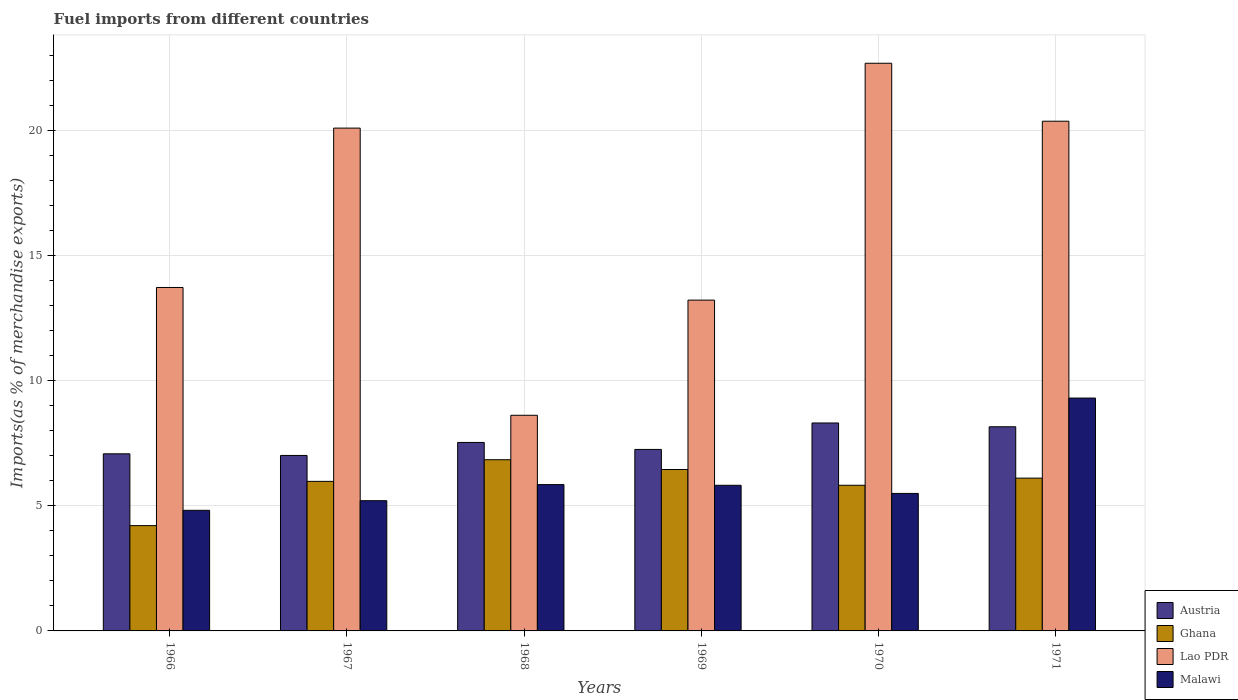How many different coloured bars are there?
Ensure brevity in your answer.  4. How many groups of bars are there?
Ensure brevity in your answer.  6. Are the number of bars per tick equal to the number of legend labels?
Give a very brief answer. Yes. Are the number of bars on each tick of the X-axis equal?
Make the answer very short. Yes. How many bars are there on the 2nd tick from the right?
Make the answer very short. 4. What is the label of the 6th group of bars from the left?
Give a very brief answer. 1971. In how many cases, is the number of bars for a given year not equal to the number of legend labels?
Your answer should be compact. 0. What is the percentage of imports to different countries in Austria in 1971?
Provide a short and direct response. 8.16. Across all years, what is the maximum percentage of imports to different countries in Austria?
Make the answer very short. 8.31. Across all years, what is the minimum percentage of imports to different countries in Ghana?
Your response must be concise. 4.21. In which year was the percentage of imports to different countries in Ghana maximum?
Keep it short and to the point. 1968. In which year was the percentage of imports to different countries in Ghana minimum?
Offer a very short reply. 1966. What is the total percentage of imports to different countries in Lao PDR in the graph?
Your answer should be compact. 98.76. What is the difference between the percentage of imports to different countries in Lao PDR in 1969 and that in 1971?
Keep it short and to the point. -7.15. What is the difference between the percentage of imports to different countries in Lao PDR in 1969 and the percentage of imports to different countries in Malawi in 1970?
Your answer should be very brief. 7.73. What is the average percentage of imports to different countries in Lao PDR per year?
Make the answer very short. 16.46. In the year 1966, what is the difference between the percentage of imports to different countries in Malawi and percentage of imports to different countries in Ghana?
Your answer should be very brief. 0.61. What is the ratio of the percentage of imports to different countries in Malawi in 1966 to that in 1969?
Ensure brevity in your answer.  0.83. Is the percentage of imports to different countries in Ghana in 1966 less than that in 1970?
Your answer should be compact. Yes. Is the difference between the percentage of imports to different countries in Malawi in 1968 and 1971 greater than the difference between the percentage of imports to different countries in Ghana in 1968 and 1971?
Keep it short and to the point. No. What is the difference between the highest and the second highest percentage of imports to different countries in Ghana?
Your response must be concise. 0.39. What is the difference between the highest and the lowest percentage of imports to different countries in Lao PDR?
Your answer should be compact. 14.07. Is it the case that in every year, the sum of the percentage of imports to different countries in Lao PDR and percentage of imports to different countries in Ghana is greater than the sum of percentage of imports to different countries in Malawi and percentage of imports to different countries in Austria?
Keep it short and to the point. Yes. What does the 4th bar from the left in 1967 represents?
Give a very brief answer. Malawi. What does the 2nd bar from the right in 1968 represents?
Your answer should be very brief. Lao PDR. Is it the case that in every year, the sum of the percentage of imports to different countries in Lao PDR and percentage of imports to different countries in Malawi is greater than the percentage of imports to different countries in Ghana?
Provide a short and direct response. Yes. How many bars are there?
Ensure brevity in your answer.  24. Are all the bars in the graph horizontal?
Your answer should be very brief. No. How many years are there in the graph?
Offer a terse response. 6. Does the graph contain any zero values?
Offer a very short reply. No. Does the graph contain grids?
Provide a succinct answer. Yes. What is the title of the graph?
Provide a short and direct response. Fuel imports from different countries. Does "Chile" appear as one of the legend labels in the graph?
Ensure brevity in your answer.  No. What is the label or title of the X-axis?
Your answer should be very brief. Years. What is the label or title of the Y-axis?
Offer a very short reply. Imports(as % of merchandise exports). What is the Imports(as % of merchandise exports) in Austria in 1966?
Your response must be concise. 7.08. What is the Imports(as % of merchandise exports) in Ghana in 1966?
Your answer should be very brief. 4.21. What is the Imports(as % of merchandise exports) in Lao PDR in 1966?
Provide a succinct answer. 13.73. What is the Imports(as % of merchandise exports) of Malawi in 1966?
Offer a terse response. 4.82. What is the Imports(as % of merchandise exports) in Austria in 1967?
Keep it short and to the point. 7.02. What is the Imports(as % of merchandise exports) of Ghana in 1967?
Give a very brief answer. 5.98. What is the Imports(as % of merchandise exports) in Lao PDR in 1967?
Your response must be concise. 20.1. What is the Imports(as % of merchandise exports) in Malawi in 1967?
Your answer should be very brief. 5.21. What is the Imports(as % of merchandise exports) of Austria in 1968?
Make the answer very short. 7.54. What is the Imports(as % of merchandise exports) of Ghana in 1968?
Make the answer very short. 6.84. What is the Imports(as % of merchandise exports) in Lao PDR in 1968?
Offer a terse response. 8.62. What is the Imports(as % of merchandise exports) in Malawi in 1968?
Offer a very short reply. 5.85. What is the Imports(as % of merchandise exports) of Austria in 1969?
Keep it short and to the point. 7.26. What is the Imports(as % of merchandise exports) of Ghana in 1969?
Offer a terse response. 6.45. What is the Imports(as % of merchandise exports) in Lao PDR in 1969?
Give a very brief answer. 13.23. What is the Imports(as % of merchandise exports) of Malawi in 1969?
Offer a terse response. 5.82. What is the Imports(as % of merchandise exports) in Austria in 1970?
Your response must be concise. 8.31. What is the Imports(as % of merchandise exports) in Ghana in 1970?
Offer a terse response. 5.82. What is the Imports(as % of merchandise exports) of Lao PDR in 1970?
Give a very brief answer. 22.7. What is the Imports(as % of merchandise exports) of Malawi in 1970?
Keep it short and to the point. 5.5. What is the Imports(as % of merchandise exports) in Austria in 1971?
Make the answer very short. 8.16. What is the Imports(as % of merchandise exports) in Ghana in 1971?
Keep it short and to the point. 6.11. What is the Imports(as % of merchandise exports) in Lao PDR in 1971?
Provide a succinct answer. 20.38. What is the Imports(as % of merchandise exports) in Malawi in 1971?
Your response must be concise. 9.31. Across all years, what is the maximum Imports(as % of merchandise exports) of Austria?
Your response must be concise. 8.31. Across all years, what is the maximum Imports(as % of merchandise exports) of Ghana?
Your answer should be very brief. 6.84. Across all years, what is the maximum Imports(as % of merchandise exports) in Lao PDR?
Keep it short and to the point. 22.7. Across all years, what is the maximum Imports(as % of merchandise exports) of Malawi?
Offer a very short reply. 9.31. Across all years, what is the minimum Imports(as % of merchandise exports) in Austria?
Your response must be concise. 7.02. Across all years, what is the minimum Imports(as % of merchandise exports) of Ghana?
Keep it short and to the point. 4.21. Across all years, what is the minimum Imports(as % of merchandise exports) of Lao PDR?
Offer a very short reply. 8.62. Across all years, what is the minimum Imports(as % of merchandise exports) of Malawi?
Keep it short and to the point. 4.82. What is the total Imports(as % of merchandise exports) in Austria in the graph?
Your response must be concise. 45.37. What is the total Imports(as % of merchandise exports) in Ghana in the graph?
Your answer should be compact. 35.42. What is the total Imports(as % of merchandise exports) of Lao PDR in the graph?
Provide a succinct answer. 98.76. What is the total Imports(as % of merchandise exports) in Malawi in the graph?
Your answer should be compact. 36.51. What is the difference between the Imports(as % of merchandise exports) in Austria in 1966 and that in 1967?
Your answer should be compact. 0.07. What is the difference between the Imports(as % of merchandise exports) in Ghana in 1966 and that in 1967?
Make the answer very short. -1.77. What is the difference between the Imports(as % of merchandise exports) in Lao PDR in 1966 and that in 1967?
Offer a terse response. -6.37. What is the difference between the Imports(as % of merchandise exports) in Malawi in 1966 and that in 1967?
Your answer should be compact. -0.39. What is the difference between the Imports(as % of merchandise exports) of Austria in 1966 and that in 1968?
Ensure brevity in your answer.  -0.45. What is the difference between the Imports(as % of merchandise exports) in Ghana in 1966 and that in 1968?
Keep it short and to the point. -2.63. What is the difference between the Imports(as % of merchandise exports) of Lao PDR in 1966 and that in 1968?
Your answer should be very brief. 5.11. What is the difference between the Imports(as % of merchandise exports) in Malawi in 1966 and that in 1968?
Provide a short and direct response. -1.03. What is the difference between the Imports(as % of merchandise exports) of Austria in 1966 and that in 1969?
Offer a very short reply. -0.18. What is the difference between the Imports(as % of merchandise exports) of Ghana in 1966 and that in 1969?
Your answer should be very brief. -2.24. What is the difference between the Imports(as % of merchandise exports) of Lao PDR in 1966 and that in 1969?
Your answer should be compact. 0.51. What is the difference between the Imports(as % of merchandise exports) in Malawi in 1966 and that in 1969?
Make the answer very short. -1. What is the difference between the Imports(as % of merchandise exports) in Austria in 1966 and that in 1970?
Offer a terse response. -1.23. What is the difference between the Imports(as % of merchandise exports) in Ghana in 1966 and that in 1970?
Offer a terse response. -1.61. What is the difference between the Imports(as % of merchandise exports) of Lao PDR in 1966 and that in 1970?
Keep it short and to the point. -8.96. What is the difference between the Imports(as % of merchandise exports) of Malawi in 1966 and that in 1970?
Provide a succinct answer. -0.68. What is the difference between the Imports(as % of merchandise exports) of Austria in 1966 and that in 1971?
Your answer should be very brief. -1.08. What is the difference between the Imports(as % of merchandise exports) of Ghana in 1966 and that in 1971?
Your answer should be compact. -1.9. What is the difference between the Imports(as % of merchandise exports) of Lao PDR in 1966 and that in 1971?
Provide a short and direct response. -6.65. What is the difference between the Imports(as % of merchandise exports) of Malawi in 1966 and that in 1971?
Give a very brief answer. -4.49. What is the difference between the Imports(as % of merchandise exports) of Austria in 1967 and that in 1968?
Your answer should be very brief. -0.52. What is the difference between the Imports(as % of merchandise exports) in Ghana in 1967 and that in 1968?
Give a very brief answer. -0.87. What is the difference between the Imports(as % of merchandise exports) of Lao PDR in 1967 and that in 1968?
Provide a short and direct response. 11.48. What is the difference between the Imports(as % of merchandise exports) of Malawi in 1967 and that in 1968?
Provide a short and direct response. -0.64. What is the difference between the Imports(as % of merchandise exports) of Austria in 1967 and that in 1969?
Make the answer very short. -0.24. What is the difference between the Imports(as % of merchandise exports) of Ghana in 1967 and that in 1969?
Your answer should be compact. -0.47. What is the difference between the Imports(as % of merchandise exports) in Lao PDR in 1967 and that in 1969?
Provide a short and direct response. 6.88. What is the difference between the Imports(as % of merchandise exports) of Malawi in 1967 and that in 1969?
Your answer should be compact. -0.62. What is the difference between the Imports(as % of merchandise exports) of Austria in 1967 and that in 1970?
Give a very brief answer. -1.3. What is the difference between the Imports(as % of merchandise exports) in Ghana in 1967 and that in 1970?
Provide a short and direct response. 0.16. What is the difference between the Imports(as % of merchandise exports) in Lao PDR in 1967 and that in 1970?
Provide a succinct answer. -2.59. What is the difference between the Imports(as % of merchandise exports) of Malawi in 1967 and that in 1970?
Your answer should be very brief. -0.29. What is the difference between the Imports(as % of merchandise exports) in Austria in 1967 and that in 1971?
Make the answer very short. -1.15. What is the difference between the Imports(as % of merchandise exports) of Ghana in 1967 and that in 1971?
Provide a short and direct response. -0.13. What is the difference between the Imports(as % of merchandise exports) of Lao PDR in 1967 and that in 1971?
Keep it short and to the point. -0.28. What is the difference between the Imports(as % of merchandise exports) of Malawi in 1967 and that in 1971?
Make the answer very short. -4.1. What is the difference between the Imports(as % of merchandise exports) of Austria in 1968 and that in 1969?
Provide a succinct answer. 0.28. What is the difference between the Imports(as % of merchandise exports) of Ghana in 1968 and that in 1969?
Keep it short and to the point. 0.39. What is the difference between the Imports(as % of merchandise exports) in Lao PDR in 1968 and that in 1969?
Provide a short and direct response. -4.6. What is the difference between the Imports(as % of merchandise exports) of Malawi in 1968 and that in 1969?
Ensure brevity in your answer.  0.03. What is the difference between the Imports(as % of merchandise exports) of Austria in 1968 and that in 1970?
Provide a short and direct response. -0.78. What is the difference between the Imports(as % of merchandise exports) in Ghana in 1968 and that in 1970?
Your response must be concise. 1.02. What is the difference between the Imports(as % of merchandise exports) of Lao PDR in 1968 and that in 1970?
Keep it short and to the point. -14.07. What is the difference between the Imports(as % of merchandise exports) of Malawi in 1968 and that in 1970?
Give a very brief answer. 0.35. What is the difference between the Imports(as % of merchandise exports) in Austria in 1968 and that in 1971?
Provide a short and direct response. -0.63. What is the difference between the Imports(as % of merchandise exports) in Ghana in 1968 and that in 1971?
Your answer should be compact. 0.74. What is the difference between the Imports(as % of merchandise exports) in Lao PDR in 1968 and that in 1971?
Your answer should be very brief. -11.76. What is the difference between the Imports(as % of merchandise exports) of Malawi in 1968 and that in 1971?
Give a very brief answer. -3.46. What is the difference between the Imports(as % of merchandise exports) in Austria in 1969 and that in 1970?
Your answer should be compact. -1.06. What is the difference between the Imports(as % of merchandise exports) of Ghana in 1969 and that in 1970?
Your answer should be very brief. 0.63. What is the difference between the Imports(as % of merchandise exports) in Lao PDR in 1969 and that in 1970?
Offer a very short reply. -9.47. What is the difference between the Imports(as % of merchandise exports) in Malawi in 1969 and that in 1970?
Give a very brief answer. 0.33. What is the difference between the Imports(as % of merchandise exports) in Austria in 1969 and that in 1971?
Keep it short and to the point. -0.91. What is the difference between the Imports(as % of merchandise exports) of Ghana in 1969 and that in 1971?
Give a very brief answer. 0.34. What is the difference between the Imports(as % of merchandise exports) in Lao PDR in 1969 and that in 1971?
Offer a terse response. -7.15. What is the difference between the Imports(as % of merchandise exports) of Malawi in 1969 and that in 1971?
Provide a succinct answer. -3.49. What is the difference between the Imports(as % of merchandise exports) of Austria in 1970 and that in 1971?
Offer a very short reply. 0.15. What is the difference between the Imports(as % of merchandise exports) of Ghana in 1970 and that in 1971?
Your response must be concise. -0.29. What is the difference between the Imports(as % of merchandise exports) in Lao PDR in 1970 and that in 1971?
Keep it short and to the point. 2.32. What is the difference between the Imports(as % of merchandise exports) in Malawi in 1970 and that in 1971?
Provide a succinct answer. -3.81. What is the difference between the Imports(as % of merchandise exports) in Austria in 1966 and the Imports(as % of merchandise exports) in Ghana in 1967?
Provide a short and direct response. 1.1. What is the difference between the Imports(as % of merchandise exports) of Austria in 1966 and the Imports(as % of merchandise exports) of Lao PDR in 1967?
Provide a succinct answer. -13.02. What is the difference between the Imports(as % of merchandise exports) in Austria in 1966 and the Imports(as % of merchandise exports) in Malawi in 1967?
Make the answer very short. 1.87. What is the difference between the Imports(as % of merchandise exports) of Ghana in 1966 and the Imports(as % of merchandise exports) of Lao PDR in 1967?
Your answer should be compact. -15.89. What is the difference between the Imports(as % of merchandise exports) of Ghana in 1966 and the Imports(as % of merchandise exports) of Malawi in 1967?
Make the answer very short. -1. What is the difference between the Imports(as % of merchandise exports) in Lao PDR in 1966 and the Imports(as % of merchandise exports) in Malawi in 1967?
Give a very brief answer. 8.52. What is the difference between the Imports(as % of merchandise exports) in Austria in 1966 and the Imports(as % of merchandise exports) in Ghana in 1968?
Your answer should be very brief. 0.24. What is the difference between the Imports(as % of merchandise exports) of Austria in 1966 and the Imports(as % of merchandise exports) of Lao PDR in 1968?
Keep it short and to the point. -1.54. What is the difference between the Imports(as % of merchandise exports) in Austria in 1966 and the Imports(as % of merchandise exports) in Malawi in 1968?
Your response must be concise. 1.23. What is the difference between the Imports(as % of merchandise exports) in Ghana in 1966 and the Imports(as % of merchandise exports) in Lao PDR in 1968?
Offer a very short reply. -4.41. What is the difference between the Imports(as % of merchandise exports) in Ghana in 1966 and the Imports(as % of merchandise exports) in Malawi in 1968?
Provide a succinct answer. -1.64. What is the difference between the Imports(as % of merchandise exports) of Lao PDR in 1966 and the Imports(as % of merchandise exports) of Malawi in 1968?
Your answer should be compact. 7.88. What is the difference between the Imports(as % of merchandise exports) in Austria in 1966 and the Imports(as % of merchandise exports) in Ghana in 1969?
Your answer should be compact. 0.63. What is the difference between the Imports(as % of merchandise exports) of Austria in 1966 and the Imports(as % of merchandise exports) of Lao PDR in 1969?
Keep it short and to the point. -6.15. What is the difference between the Imports(as % of merchandise exports) in Austria in 1966 and the Imports(as % of merchandise exports) in Malawi in 1969?
Offer a terse response. 1.26. What is the difference between the Imports(as % of merchandise exports) in Ghana in 1966 and the Imports(as % of merchandise exports) in Lao PDR in 1969?
Provide a succinct answer. -9.02. What is the difference between the Imports(as % of merchandise exports) of Ghana in 1966 and the Imports(as % of merchandise exports) of Malawi in 1969?
Your answer should be very brief. -1.61. What is the difference between the Imports(as % of merchandise exports) in Lao PDR in 1966 and the Imports(as % of merchandise exports) in Malawi in 1969?
Ensure brevity in your answer.  7.91. What is the difference between the Imports(as % of merchandise exports) of Austria in 1966 and the Imports(as % of merchandise exports) of Ghana in 1970?
Make the answer very short. 1.26. What is the difference between the Imports(as % of merchandise exports) in Austria in 1966 and the Imports(as % of merchandise exports) in Lao PDR in 1970?
Offer a very short reply. -15.62. What is the difference between the Imports(as % of merchandise exports) of Austria in 1966 and the Imports(as % of merchandise exports) of Malawi in 1970?
Your answer should be very brief. 1.58. What is the difference between the Imports(as % of merchandise exports) of Ghana in 1966 and the Imports(as % of merchandise exports) of Lao PDR in 1970?
Offer a very short reply. -18.49. What is the difference between the Imports(as % of merchandise exports) of Ghana in 1966 and the Imports(as % of merchandise exports) of Malawi in 1970?
Your answer should be very brief. -1.29. What is the difference between the Imports(as % of merchandise exports) in Lao PDR in 1966 and the Imports(as % of merchandise exports) in Malawi in 1970?
Offer a very short reply. 8.23. What is the difference between the Imports(as % of merchandise exports) of Austria in 1966 and the Imports(as % of merchandise exports) of Ghana in 1971?
Offer a terse response. 0.97. What is the difference between the Imports(as % of merchandise exports) in Austria in 1966 and the Imports(as % of merchandise exports) in Lao PDR in 1971?
Offer a very short reply. -13.3. What is the difference between the Imports(as % of merchandise exports) in Austria in 1966 and the Imports(as % of merchandise exports) in Malawi in 1971?
Provide a short and direct response. -2.23. What is the difference between the Imports(as % of merchandise exports) of Ghana in 1966 and the Imports(as % of merchandise exports) of Lao PDR in 1971?
Provide a succinct answer. -16.17. What is the difference between the Imports(as % of merchandise exports) in Ghana in 1966 and the Imports(as % of merchandise exports) in Malawi in 1971?
Your response must be concise. -5.1. What is the difference between the Imports(as % of merchandise exports) of Lao PDR in 1966 and the Imports(as % of merchandise exports) of Malawi in 1971?
Offer a very short reply. 4.42. What is the difference between the Imports(as % of merchandise exports) of Austria in 1967 and the Imports(as % of merchandise exports) of Ghana in 1968?
Make the answer very short. 0.17. What is the difference between the Imports(as % of merchandise exports) in Austria in 1967 and the Imports(as % of merchandise exports) in Lao PDR in 1968?
Offer a terse response. -1.61. What is the difference between the Imports(as % of merchandise exports) in Austria in 1967 and the Imports(as % of merchandise exports) in Malawi in 1968?
Make the answer very short. 1.17. What is the difference between the Imports(as % of merchandise exports) in Ghana in 1967 and the Imports(as % of merchandise exports) in Lao PDR in 1968?
Your response must be concise. -2.64. What is the difference between the Imports(as % of merchandise exports) in Ghana in 1967 and the Imports(as % of merchandise exports) in Malawi in 1968?
Provide a succinct answer. 0.13. What is the difference between the Imports(as % of merchandise exports) of Lao PDR in 1967 and the Imports(as % of merchandise exports) of Malawi in 1968?
Provide a short and direct response. 14.25. What is the difference between the Imports(as % of merchandise exports) in Austria in 1967 and the Imports(as % of merchandise exports) in Ghana in 1969?
Your answer should be compact. 0.56. What is the difference between the Imports(as % of merchandise exports) of Austria in 1967 and the Imports(as % of merchandise exports) of Lao PDR in 1969?
Your response must be concise. -6.21. What is the difference between the Imports(as % of merchandise exports) of Austria in 1967 and the Imports(as % of merchandise exports) of Malawi in 1969?
Give a very brief answer. 1.19. What is the difference between the Imports(as % of merchandise exports) of Ghana in 1967 and the Imports(as % of merchandise exports) of Lao PDR in 1969?
Ensure brevity in your answer.  -7.25. What is the difference between the Imports(as % of merchandise exports) in Ghana in 1967 and the Imports(as % of merchandise exports) in Malawi in 1969?
Give a very brief answer. 0.16. What is the difference between the Imports(as % of merchandise exports) of Lao PDR in 1967 and the Imports(as % of merchandise exports) of Malawi in 1969?
Offer a very short reply. 14.28. What is the difference between the Imports(as % of merchandise exports) in Austria in 1967 and the Imports(as % of merchandise exports) in Ghana in 1970?
Provide a succinct answer. 1.19. What is the difference between the Imports(as % of merchandise exports) of Austria in 1967 and the Imports(as % of merchandise exports) of Lao PDR in 1970?
Your response must be concise. -15.68. What is the difference between the Imports(as % of merchandise exports) of Austria in 1967 and the Imports(as % of merchandise exports) of Malawi in 1970?
Offer a terse response. 1.52. What is the difference between the Imports(as % of merchandise exports) in Ghana in 1967 and the Imports(as % of merchandise exports) in Lao PDR in 1970?
Offer a terse response. -16.72. What is the difference between the Imports(as % of merchandise exports) of Ghana in 1967 and the Imports(as % of merchandise exports) of Malawi in 1970?
Provide a succinct answer. 0.48. What is the difference between the Imports(as % of merchandise exports) of Lao PDR in 1967 and the Imports(as % of merchandise exports) of Malawi in 1970?
Make the answer very short. 14.61. What is the difference between the Imports(as % of merchandise exports) of Austria in 1967 and the Imports(as % of merchandise exports) of Ghana in 1971?
Make the answer very short. 0.91. What is the difference between the Imports(as % of merchandise exports) in Austria in 1967 and the Imports(as % of merchandise exports) in Lao PDR in 1971?
Provide a short and direct response. -13.36. What is the difference between the Imports(as % of merchandise exports) of Austria in 1967 and the Imports(as % of merchandise exports) of Malawi in 1971?
Your response must be concise. -2.29. What is the difference between the Imports(as % of merchandise exports) of Ghana in 1967 and the Imports(as % of merchandise exports) of Lao PDR in 1971?
Your response must be concise. -14.4. What is the difference between the Imports(as % of merchandise exports) of Ghana in 1967 and the Imports(as % of merchandise exports) of Malawi in 1971?
Make the answer very short. -3.33. What is the difference between the Imports(as % of merchandise exports) in Lao PDR in 1967 and the Imports(as % of merchandise exports) in Malawi in 1971?
Your answer should be compact. 10.79. What is the difference between the Imports(as % of merchandise exports) of Austria in 1968 and the Imports(as % of merchandise exports) of Ghana in 1969?
Your response must be concise. 1.08. What is the difference between the Imports(as % of merchandise exports) of Austria in 1968 and the Imports(as % of merchandise exports) of Lao PDR in 1969?
Your answer should be very brief. -5.69. What is the difference between the Imports(as % of merchandise exports) of Austria in 1968 and the Imports(as % of merchandise exports) of Malawi in 1969?
Your answer should be very brief. 1.71. What is the difference between the Imports(as % of merchandise exports) in Ghana in 1968 and the Imports(as % of merchandise exports) in Lao PDR in 1969?
Offer a very short reply. -6.38. What is the difference between the Imports(as % of merchandise exports) in Ghana in 1968 and the Imports(as % of merchandise exports) in Malawi in 1969?
Ensure brevity in your answer.  1.02. What is the difference between the Imports(as % of merchandise exports) of Lao PDR in 1968 and the Imports(as % of merchandise exports) of Malawi in 1969?
Make the answer very short. 2.8. What is the difference between the Imports(as % of merchandise exports) of Austria in 1968 and the Imports(as % of merchandise exports) of Ghana in 1970?
Provide a short and direct response. 1.71. What is the difference between the Imports(as % of merchandise exports) in Austria in 1968 and the Imports(as % of merchandise exports) in Lao PDR in 1970?
Ensure brevity in your answer.  -15.16. What is the difference between the Imports(as % of merchandise exports) in Austria in 1968 and the Imports(as % of merchandise exports) in Malawi in 1970?
Offer a terse response. 2.04. What is the difference between the Imports(as % of merchandise exports) in Ghana in 1968 and the Imports(as % of merchandise exports) in Lao PDR in 1970?
Offer a terse response. -15.85. What is the difference between the Imports(as % of merchandise exports) in Ghana in 1968 and the Imports(as % of merchandise exports) in Malawi in 1970?
Your answer should be very brief. 1.35. What is the difference between the Imports(as % of merchandise exports) of Lao PDR in 1968 and the Imports(as % of merchandise exports) of Malawi in 1970?
Keep it short and to the point. 3.13. What is the difference between the Imports(as % of merchandise exports) in Austria in 1968 and the Imports(as % of merchandise exports) in Ghana in 1971?
Make the answer very short. 1.43. What is the difference between the Imports(as % of merchandise exports) in Austria in 1968 and the Imports(as % of merchandise exports) in Lao PDR in 1971?
Your response must be concise. -12.84. What is the difference between the Imports(as % of merchandise exports) in Austria in 1968 and the Imports(as % of merchandise exports) in Malawi in 1971?
Give a very brief answer. -1.77. What is the difference between the Imports(as % of merchandise exports) of Ghana in 1968 and the Imports(as % of merchandise exports) of Lao PDR in 1971?
Keep it short and to the point. -13.53. What is the difference between the Imports(as % of merchandise exports) in Ghana in 1968 and the Imports(as % of merchandise exports) in Malawi in 1971?
Your response must be concise. -2.47. What is the difference between the Imports(as % of merchandise exports) of Lao PDR in 1968 and the Imports(as % of merchandise exports) of Malawi in 1971?
Make the answer very short. -0.69. What is the difference between the Imports(as % of merchandise exports) in Austria in 1969 and the Imports(as % of merchandise exports) in Ghana in 1970?
Offer a very short reply. 1.43. What is the difference between the Imports(as % of merchandise exports) in Austria in 1969 and the Imports(as % of merchandise exports) in Lao PDR in 1970?
Provide a short and direct response. -15.44. What is the difference between the Imports(as % of merchandise exports) in Austria in 1969 and the Imports(as % of merchandise exports) in Malawi in 1970?
Ensure brevity in your answer.  1.76. What is the difference between the Imports(as % of merchandise exports) of Ghana in 1969 and the Imports(as % of merchandise exports) of Lao PDR in 1970?
Provide a succinct answer. -16.24. What is the difference between the Imports(as % of merchandise exports) of Ghana in 1969 and the Imports(as % of merchandise exports) of Malawi in 1970?
Offer a very short reply. 0.96. What is the difference between the Imports(as % of merchandise exports) in Lao PDR in 1969 and the Imports(as % of merchandise exports) in Malawi in 1970?
Offer a very short reply. 7.73. What is the difference between the Imports(as % of merchandise exports) of Austria in 1969 and the Imports(as % of merchandise exports) of Ghana in 1971?
Offer a terse response. 1.15. What is the difference between the Imports(as % of merchandise exports) in Austria in 1969 and the Imports(as % of merchandise exports) in Lao PDR in 1971?
Provide a short and direct response. -13.12. What is the difference between the Imports(as % of merchandise exports) in Austria in 1969 and the Imports(as % of merchandise exports) in Malawi in 1971?
Offer a terse response. -2.05. What is the difference between the Imports(as % of merchandise exports) in Ghana in 1969 and the Imports(as % of merchandise exports) in Lao PDR in 1971?
Your answer should be compact. -13.93. What is the difference between the Imports(as % of merchandise exports) of Ghana in 1969 and the Imports(as % of merchandise exports) of Malawi in 1971?
Your answer should be very brief. -2.86. What is the difference between the Imports(as % of merchandise exports) in Lao PDR in 1969 and the Imports(as % of merchandise exports) in Malawi in 1971?
Your answer should be compact. 3.92. What is the difference between the Imports(as % of merchandise exports) in Austria in 1970 and the Imports(as % of merchandise exports) in Ghana in 1971?
Offer a terse response. 2.21. What is the difference between the Imports(as % of merchandise exports) of Austria in 1970 and the Imports(as % of merchandise exports) of Lao PDR in 1971?
Your response must be concise. -12.07. What is the difference between the Imports(as % of merchandise exports) in Austria in 1970 and the Imports(as % of merchandise exports) in Malawi in 1971?
Make the answer very short. -1. What is the difference between the Imports(as % of merchandise exports) of Ghana in 1970 and the Imports(as % of merchandise exports) of Lao PDR in 1971?
Provide a succinct answer. -14.56. What is the difference between the Imports(as % of merchandise exports) of Ghana in 1970 and the Imports(as % of merchandise exports) of Malawi in 1971?
Keep it short and to the point. -3.49. What is the difference between the Imports(as % of merchandise exports) in Lao PDR in 1970 and the Imports(as % of merchandise exports) in Malawi in 1971?
Offer a very short reply. 13.39. What is the average Imports(as % of merchandise exports) of Austria per year?
Offer a terse response. 7.56. What is the average Imports(as % of merchandise exports) in Ghana per year?
Give a very brief answer. 5.9. What is the average Imports(as % of merchandise exports) of Lao PDR per year?
Make the answer very short. 16.46. What is the average Imports(as % of merchandise exports) of Malawi per year?
Make the answer very short. 6.08. In the year 1966, what is the difference between the Imports(as % of merchandise exports) in Austria and Imports(as % of merchandise exports) in Ghana?
Provide a short and direct response. 2.87. In the year 1966, what is the difference between the Imports(as % of merchandise exports) in Austria and Imports(as % of merchandise exports) in Lao PDR?
Make the answer very short. -6.65. In the year 1966, what is the difference between the Imports(as % of merchandise exports) in Austria and Imports(as % of merchandise exports) in Malawi?
Provide a short and direct response. 2.26. In the year 1966, what is the difference between the Imports(as % of merchandise exports) of Ghana and Imports(as % of merchandise exports) of Lao PDR?
Your answer should be compact. -9.52. In the year 1966, what is the difference between the Imports(as % of merchandise exports) of Ghana and Imports(as % of merchandise exports) of Malawi?
Your answer should be compact. -0.61. In the year 1966, what is the difference between the Imports(as % of merchandise exports) of Lao PDR and Imports(as % of merchandise exports) of Malawi?
Provide a short and direct response. 8.91. In the year 1967, what is the difference between the Imports(as % of merchandise exports) in Austria and Imports(as % of merchandise exports) in Ghana?
Provide a succinct answer. 1.04. In the year 1967, what is the difference between the Imports(as % of merchandise exports) of Austria and Imports(as % of merchandise exports) of Lao PDR?
Provide a short and direct response. -13.09. In the year 1967, what is the difference between the Imports(as % of merchandise exports) in Austria and Imports(as % of merchandise exports) in Malawi?
Your answer should be compact. 1.81. In the year 1967, what is the difference between the Imports(as % of merchandise exports) in Ghana and Imports(as % of merchandise exports) in Lao PDR?
Offer a very short reply. -14.12. In the year 1967, what is the difference between the Imports(as % of merchandise exports) in Ghana and Imports(as % of merchandise exports) in Malawi?
Your response must be concise. 0.77. In the year 1967, what is the difference between the Imports(as % of merchandise exports) in Lao PDR and Imports(as % of merchandise exports) in Malawi?
Make the answer very short. 14.9. In the year 1968, what is the difference between the Imports(as % of merchandise exports) of Austria and Imports(as % of merchandise exports) of Ghana?
Make the answer very short. 0.69. In the year 1968, what is the difference between the Imports(as % of merchandise exports) of Austria and Imports(as % of merchandise exports) of Lao PDR?
Make the answer very short. -1.09. In the year 1968, what is the difference between the Imports(as % of merchandise exports) of Austria and Imports(as % of merchandise exports) of Malawi?
Offer a terse response. 1.69. In the year 1968, what is the difference between the Imports(as % of merchandise exports) of Ghana and Imports(as % of merchandise exports) of Lao PDR?
Your response must be concise. -1.78. In the year 1968, what is the difference between the Imports(as % of merchandise exports) of Lao PDR and Imports(as % of merchandise exports) of Malawi?
Provide a succinct answer. 2.77. In the year 1969, what is the difference between the Imports(as % of merchandise exports) in Austria and Imports(as % of merchandise exports) in Ghana?
Ensure brevity in your answer.  0.8. In the year 1969, what is the difference between the Imports(as % of merchandise exports) in Austria and Imports(as % of merchandise exports) in Lao PDR?
Give a very brief answer. -5.97. In the year 1969, what is the difference between the Imports(as % of merchandise exports) of Austria and Imports(as % of merchandise exports) of Malawi?
Your answer should be compact. 1.43. In the year 1969, what is the difference between the Imports(as % of merchandise exports) of Ghana and Imports(as % of merchandise exports) of Lao PDR?
Your answer should be very brief. -6.77. In the year 1969, what is the difference between the Imports(as % of merchandise exports) in Ghana and Imports(as % of merchandise exports) in Malawi?
Ensure brevity in your answer.  0.63. In the year 1969, what is the difference between the Imports(as % of merchandise exports) in Lao PDR and Imports(as % of merchandise exports) in Malawi?
Your answer should be compact. 7.4. In the year 1970, what is the difference between the Imports(as % of merchandise exports) of Austria and Imports(as % of merchandise exports) of Ghana?
Offer a very short reply. 2.49. In the year 1970, what is the difference between the Imports(as % of merchandise exports) of Austria and Imports(as % of merchandise exports) of Lao PDR?
Provide a succinct answer. -14.38. In the year 1970, what is the difference between the Imports(as % of merchandise exports) of Austria and Imports(as % of merchandise exports) of Malawi?
Your answer should be compact. 2.82. In the year 1970, what is the difference between the Imports(as % of merchandise exports) of Ghana and Imports(as % of merchandise exports) of Lao PDR?
Your response must be concise. -16.87. In the year 1970, what is the difference between the Imports(as % of merchandise exports) in Ghana and Imports(as % of merchandise exports) in Malawi?
Provide a short and direct response. 0.33. In the year 1970, what is the difference between the Imports(as % of merchandise exports) in Lao PDR and Imports(as % of merchandise exports) in Malawi?
Your answer should be very brief. 17.2. In the year 1971, what is the difference between the Imports(as % of merchandise exports) in Austria and Imports(as % of merchandise exports) in Ghana?
Offer a terse response. 2.05. In the year 1971, what is the difference between the Imports(as % of merchandise exports) of Austria and Imports(as % of merchandise exports) of Lao PDR?
Provide a succinct answer. -12.22. In the year 1971, what is the difference between the Imports(as % of merchandise exports) of Austria and Imports(as % of merchandise exports) of Malawi?
Keep it short and to the point. -1.15. In the year 1971, what is the difference between the Imports(as % of merchandise exports) in Ghana and Imports(as % of merchandise exports) in Lao PDR?
Your answer should be very brief. -14.27. In the year 1971, what is the difference between the Imports(as % of merchandise exports) of Ghana and Imports(as % of merchandise exports) of Malawi?
Provide a short and direct response. -3.2. In the year 1971, what is the difference between the Imports(as % of merchandise exports) of Lao PDR and Imports(as % of merchandise exports) of Malawi?
Give a very brief answer. 11.07. What is the ratio of the Imports(as % of merchandise exports) in Austria in 1966 to that in 1967?
Your response must be concise. 1.01. What is the ratio of the Imports(as % of merchandise exports) in Ghana in 1966 to that in 1967?
Provide a succinct answer. 0.7. What is the ratio of the Imports(as % of merchandise exports) of Lao PDR in 1966 to that in 1967?
Your answer should be compact. 0.68. What is the ratio of the Imports(as % of merchandise exports) in Malawi in 1966 to that in 1967?
Your answer should be very brief. 0.93. What is the ratio of the Imports(as % of merchandise exports) in Austria in 1966 to that in 1968?
Your answer should be very brief. 0.94. What is the ratio of the Imports(as % of merchandise exports) of Ghana in 1966 to that in 1968?
Ensure brevity in your answer.  0.62. What is the ratio of the Imports(as % of merchandise exports) of Lao PDR in 1966 to that in 1968?
Your response must be concise. 1.59. What is the ratio of the Imports(as % of merchandise exports) of Malawi in 1966 to that in 1968?
Your response must be concise. 0.82. What is the ratio of the Imports(as % of merchandise exports) in Austria in 1966 to that in 1969?
Keep it short and to the point. 0.98. What is the ratio of the Imports(as % of merchandise exports) of Ghana in 1966 to that in 1969?
Keep it short and to the point. 0.65. What is the ratio of the Imports(as % of merchandise exports) in Lao PDR in 1966 to that in 1969?
Make the answer very short. 1.04. What is the ratio of the Imports(as % of merchandise exports) of Malawi in 1966 to that in 1969?
Offer a terse response. 0.83. What is the ratio of the Imports(as % of merchandise exports) in Austria in 1966 to that in 1970?
Your response must be concise. 0.85. What is the ratio of the Imports(as % of merchandise exports) of Ghana in 1966 to that in 1970?
Your answer should be compact. 0.72. What is the ratio of the Imports(as % of merchandise exports) of Lao PDR in 1966 to that in 1970?
Offer a very short reply. 0.6. What is the ratio of the Imports(as % of merchandise exports) in Malawi in 1966 to that in 1970?
Make the answer very short. 0.88. What is the ratio of the Imports(as % of merchandise exports) of Austria in 1966 to that in 1971?
Keep it short and to the point. 0.87. What is the ratio of the Imports(as % of merchandise exports) in Ghana in 1966 to that in 1971?
Ensure brevity in your answer.  0.69. What is the ratio of the Imports(as % of merchandise exports) of Lao PDR in 1966 to that in 1971?
Offer a very short reply. 0.67. What is the ratio of the Imports(as % of merchandise exports) of Malawi in 1966 to that in 1971?
Ensure brevity in your answer.  0.52. What is the ratio of the Imports(as % of merchandise exports) in Austria in 1967 to that in 1968?
Offer a very short reply. 0.93. What is the ratio of the Imports(as % of merchandise exports) in Ghana in 1967 to that in 1968?
Offer a terse response. 0.87. What is the ratio of the Imports(as % of merchandise exports) in Lao PDR in 1967 to that in 1968?
Ensure brevity in your answer.  2.33. What is the ratio of the Imports(as % of merchandise exports) of Malawi in 1967 to that in 1968?
Offer a very short reply. 0.89. What is the ratio of the Imports(as % of merchandise exports) in Austria in 1967 to that in 1969?
Provide a short and direct response. 0.97. What is the ratio of the Imports(as % of merchandise exports) in Ghana in 1967 to that in 1969?
Ensure brevity in your answer.  0.93. What is the ratio of the Imports(as % of merchandise exports) in Lao PDR in 1967 to that in 1969?
Your answer should be compact. 1.52. What is the ratio of the Imports(as % of merchandise exports) in Malawi in 1967 to that in 1969?
Keep it short and to the point. 0.89. What is the ratio of the Imports(as % of merchandise exports) in Austria in 1967 to that in 1970?
Keep it short and to the point. 0.84. What is the ratio of the Imports(as % of merchandise exports) in Ghana in 1967 to that in 1970?
Offer a terse response. 1.03. What is the ratio of the Imports(as % of merchandise exports) of Lao PDR in 1967 to that in 1970?
Your answer should be very brief. 0.89. What is the ratio of the Imports(as % of merchandise exports) in Malawi in 1967 to that in 1970?
Offer a terse response. 0.95. What is the ratio of the Imports(as % of merchandise exports) of Austria in 1967 to that in 1971?
Your answer should be compact. 0.86. What is the ratio of the Imports(as % of merchandise exports) in Ghana in 1967 to that in 1971?
Give a very brief answer. 0.98. What is the ratio of the Imports(as % of merchandise exports) of Lao PDR in 1967 to that in 1971?
Give a very brief answer. 0.99. What is the ratio of the Imports(as % of merchandise exports) in Malawi in 1967 to that in 1971?
Give a very brief answer. 0.56. What is the ratio of the Imports(as % of merchandise exports) in Austria in 1968 to that in 1969?
Provide a short and direct response. 1.04. What is the ratio of the Imports(as % of merchandise exports) of Ghana in 1968 to that in 1969?
Give a very brief answer. 1.06. What is the ratio of the Imports(as % of merchandise exports) in Lao PDR in 1968 to that in 1969?
Ensure brevity in your answer.  0.65. What is the ratio of the Imports(as % of merchandise exports) of Austria in 1968 to that in 1970?
Make the answer very short. 0.91. What is the ratio of the Imports(as % of merchandise exports) in Ghana in 1968 to that in 1970?
Keep it short and to the point. 1.18. What is the ratio of the Imports(as % of merchandise exports) of Lao PDR in 1968 to that in 1970?
Offer a terse response. 0.38. What is the ratio of the Imports(as % of merchandise exports) in Malawi in 1968 to that in 1970?
Your answer should be very brief. 1.06. What is the ratio of the Imports(as % of merchandise exports) in Austria in 1968 to that in 1971?
Ensure brevity in your answer.  0.92. What is the ratio of the Imports(as % of merchandise exports) of Ghana in 1968 to that in 1971?
Give a very brief answer. 1.12. What is the ratio of the Imports(as % of merchandise exports) of Lao PDR in 1968 to that in 1971?
Your response must be concise. 0.42. What is the ratio of the Imports(as % of merchandise exports) in Malawi in 1968 to that in 1971?
Give a very brief answer. 0.63. What is the ratio of the Imports(as % of merchandise exports) of Austria in 1969 to that in 1970?
Ensure brevity in your answer.  0.87. What is the ratio of the Imports(as % of merchandise exports) of Ghana in 1969 to that in 1970?
Make the answer very short. 1.11. What is the ratio of the Imports(as % of merchandise exports) of Lao PDR in 1969 to that in 1970?
Offer a very short reply. 0.58. What is the ratio of the Imports(as % of merchandise exports) of Malawi in 1969 to that in 1970?
Provide a succinct answer. 1.06. What is the ratio of the Imports(as % of merchandise exports) in Austria in 1969 to that in 1971?
Your response must be concise. 0.89. What is the ratio of the Imports(as % of merchandise exports) of Ghana in 1969 to that in 1971?
Give a very brief answer. 1.06. What is the ratio of the Imports(as % of merchandise exports) in Lao PDR in 1969 to that in 1971?
Ensure brevity in your answer.  0.65. What is the ratio of the Imports(as % of merchandise exports) of Malawi in 1969 to that in 1971?
Your answer should be very brief. 0.63. What is the ratio of the Imports(as % of merchandise exports) in Austria in 1970 to that in 1971?
Make the answer very short. 1.02. What is the ratio of the Imports(as % of merchandise exports) in Ghana in 1970 to that in 1971?
Ensure brevity in your answer.  0.95. What is the ratio of the Imports(as % of merchandise exports) in Lao PDR in 1970 to that in 1971?
Your answer should be very brief. 1.11. What is the ratio of the Imports(as % of merchandise exports) of Malawi in 1970 to that in 1971?
Offer a terse response. 0.59. What is the difference between the highest and the second highest Imports(as % of merchandise exports) of Austria?
Ensure brevity in your answer.  0.15. What is the difference between the highest and the second highest Imports(as % of merchandise exports) in Ghana?
Provide a short and direct response. 0.39. What is the difference between the highest and the second highest Imports(as % of merchandise exports) of Lao PDR?
Your answer should be very brief. 2.32. What is the difference between the highest and the second highest Imports(as % of merchandise exports) in Malawi?
Your response must be concise. 3.46. What is the difference between the highest and the lowest Imports(as % of merchandise exports) of Austria?
Keep it short and to the point. 1.3. What is the difference between the highest and the lowest Imports(as % of merchandise exports) in Ghana?
Keep it short and to the point. 2.63. What is the difference between the highest and the lowest Imports(as % of merchandise exports) in Lao PDR?
Your answer should be very brief. 14.07. What is the difference between the highest and the lowest Imports(as % of merchandise exports) in Malawi?
Your response must be concise. 4.49. 